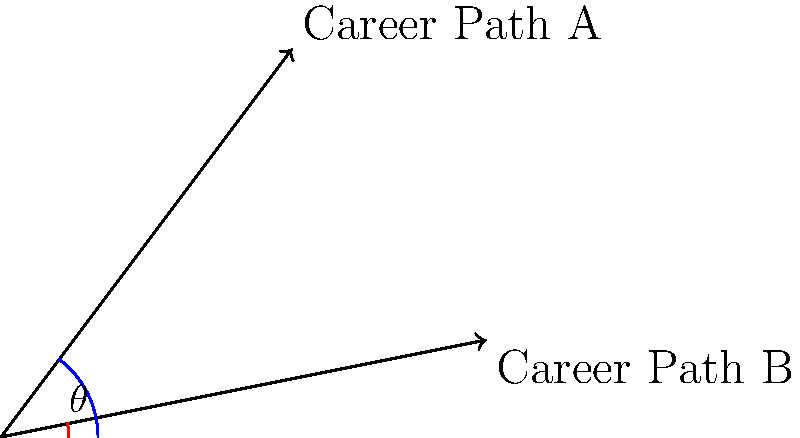As a social butterfly navigating the professional landscape, you're considering two potential career paths represented by vectors A(3,4) and B(5,1). To determine how divergent these paths are, you need to calculate the angle between them. What is the angle $\theta$ (in degrees, rounded to the nearest integer) between these two career vectors? To find the angle between two vectors, we can use the dot product formula:

$$\cos \theta = \frac{\vec{A} \cdot \vec{B}}{|\vec{A}||\vec{B}|}$$

Step 1: Calculate the dot product of A and B
$$\vec{A} \cdot \vec{B} = (3)(5) + (4)(1) = 15 + 4 = 19$$

Step 2: Calculate the magnitudes of A and B
$$|\vec{A}| = \sqrt{3^2 + 4^2} = \sqrt{9 + 16} = \sqrt{25} = 5$$
$$|\vec{B}| = \sqrt{5^2 + 1^2} = \sqrt{25 + 1} = \sqrt{26}$$

Step 3: Apply the dot product formula
$$\cos \theta = \frac{19}{5\sqrt{26}}$$

Step 4: Take the inverse cosine (arccos) of both sides
$$\theta = \arccos(\frac{19}{5\sqrt{26}})$$

Step 5: Calculate and round to the nearest integer
$$\theta \approx 22.6^\circ \approx 23^\circ$$
Answer: $23^\circ$ 